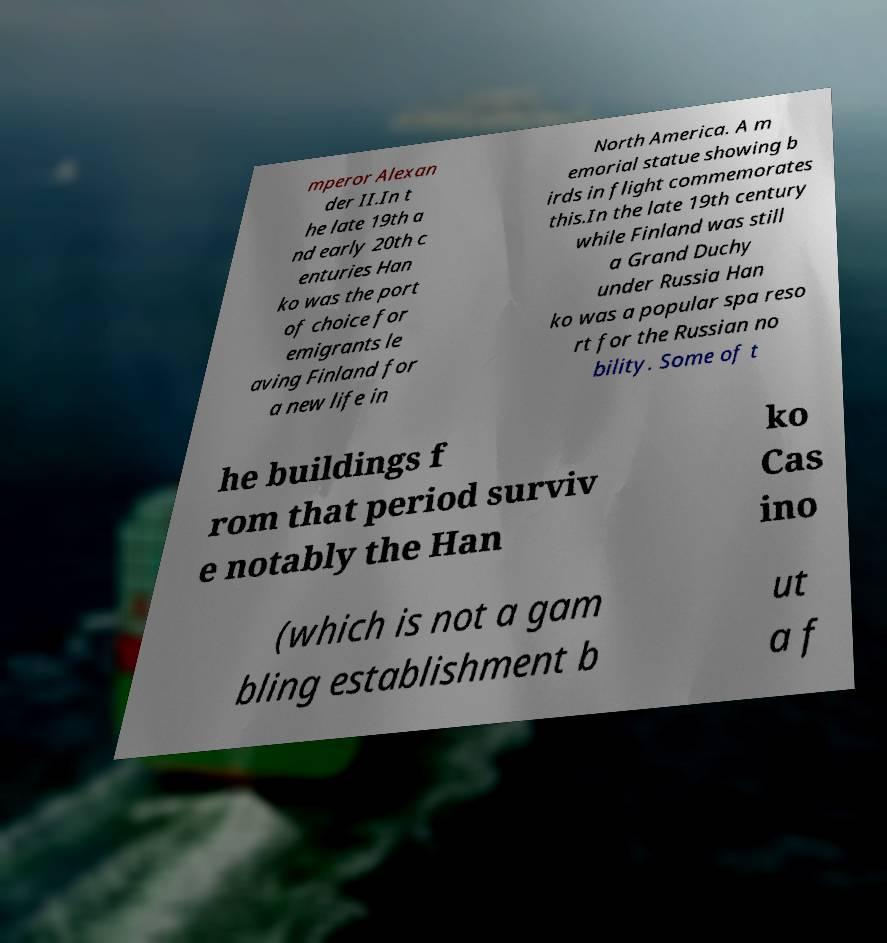Please read and relay the text visible in this image. What does it say? mperor Alexan der II.In t he late 19th a nd early 20th c enturies Han ko was the port of choice for emigrants le aving Finland for a new life in North America. A m emorial statue showing b irds in flight commemorates this.In the late 19th century while Finland was still a Grand Duchy under Russia Han ko was a popular spa reso rt for the Russian no bility. Some of t he buildings f rom that period surviv e notably the Han ko Cas ino (which is not a gam bling establishment b ut a f 